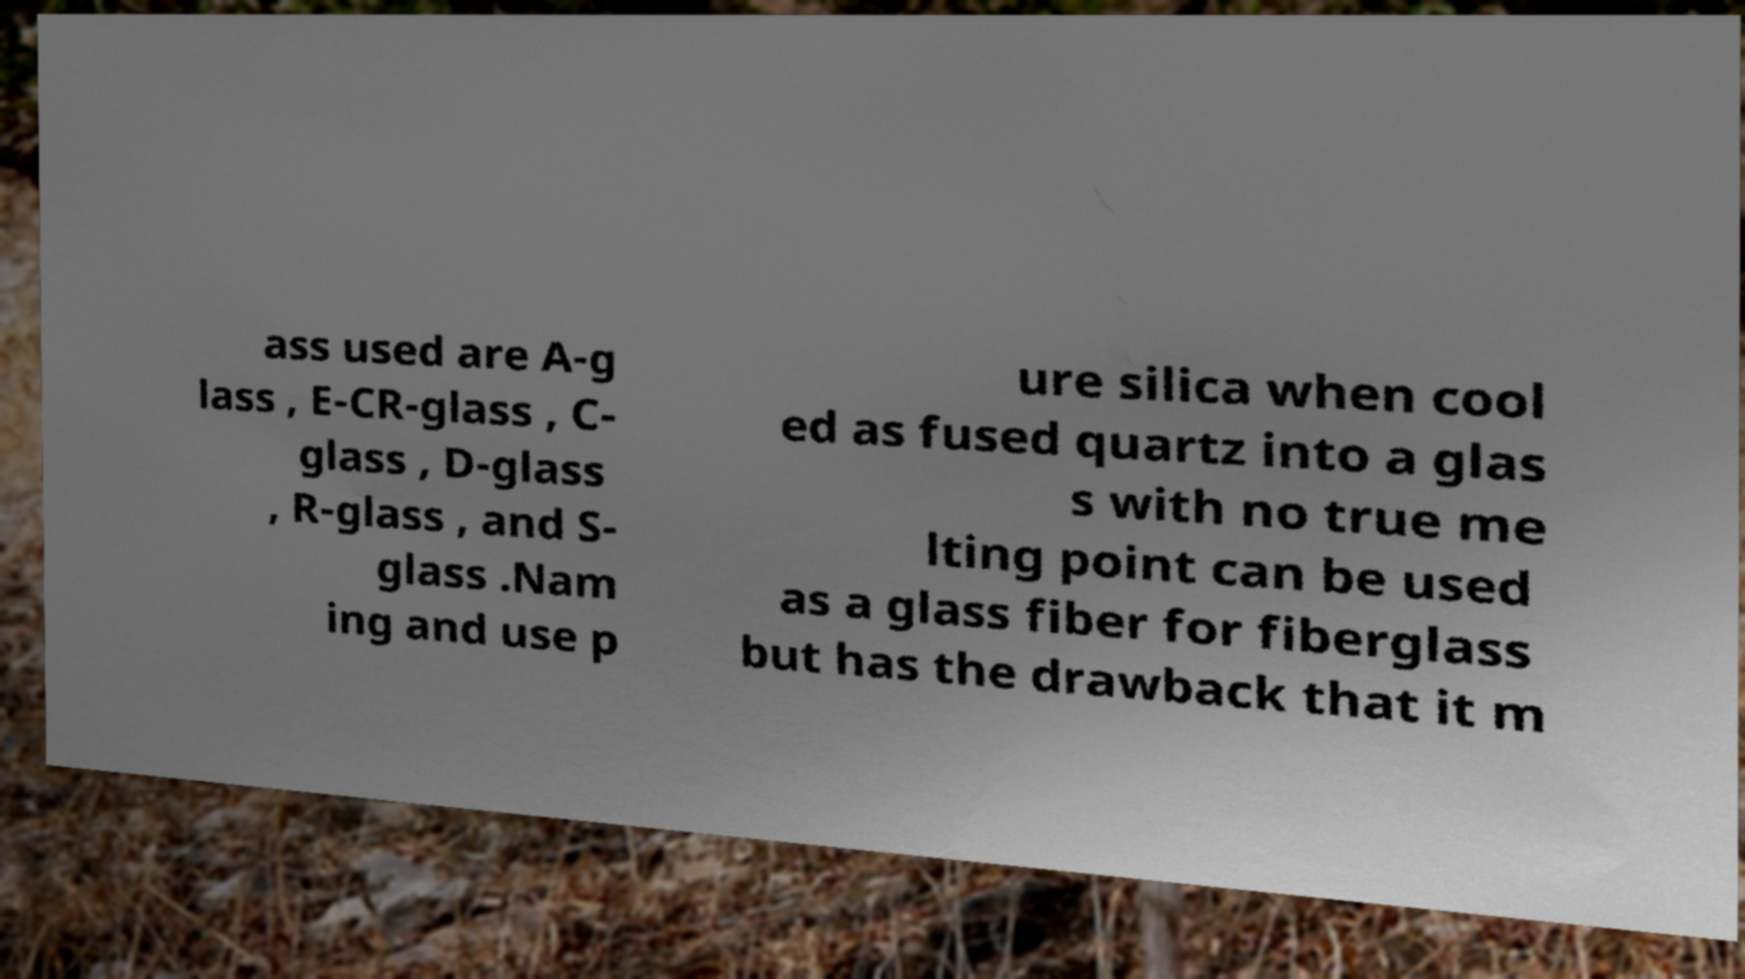Can you read and provide the text displayed in the image?This photo seems to have some interesting text. Can you extract and type it out for me? ass used are A-g lass , E-CR-glass , C- glass , D-glass , R-glass , and S- glass .Nam ing and use p ure silica when cool ed as fused quartz into a glas s with no true me lting point can be used as a glass fiber for fiberglass but has the drawback that it m 